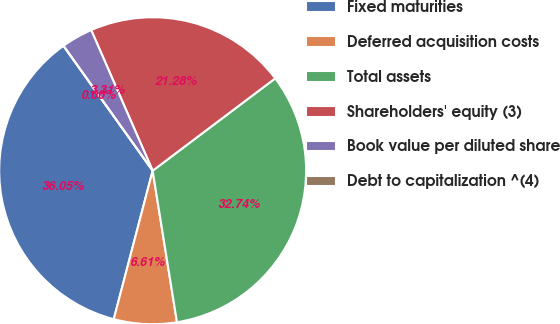Convert chart to OTSL. <chart><loc_0><loc_0><loc_500><loc_500><pie_chart><fcel>Fixed maturities<fcel>Deferred acquisition costs<fcel>Total assets<fcel>Shareholders' equity (3)<fcel>Book value per diluted share<fcel>Debt to capitalization ^(4)<nl><fcel>36.05%<fcel>6.61%<fcel>32.74%<fcel>21.28%<fcel>3.31%<fcel>0.0%<nl></chart> 